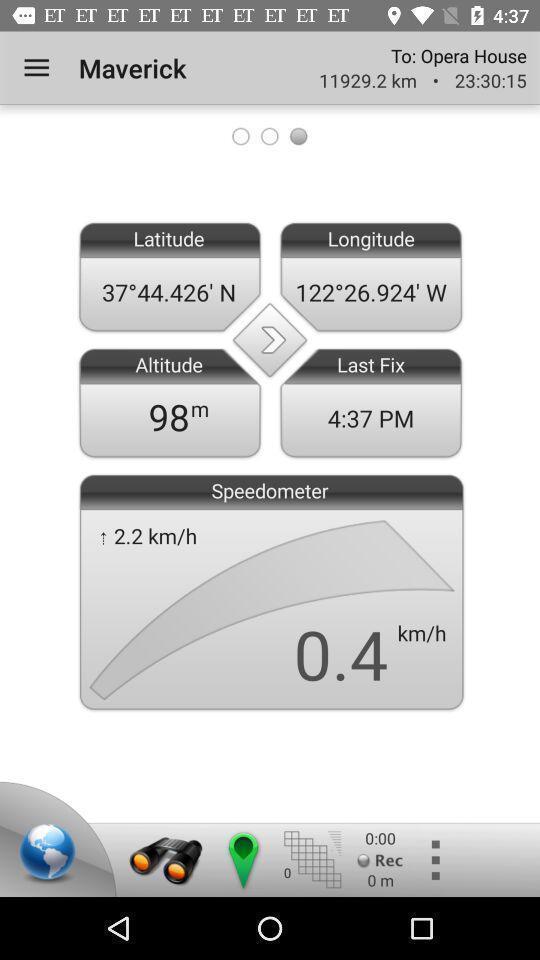Summarize the information in this screenshot. Page of a map application. 